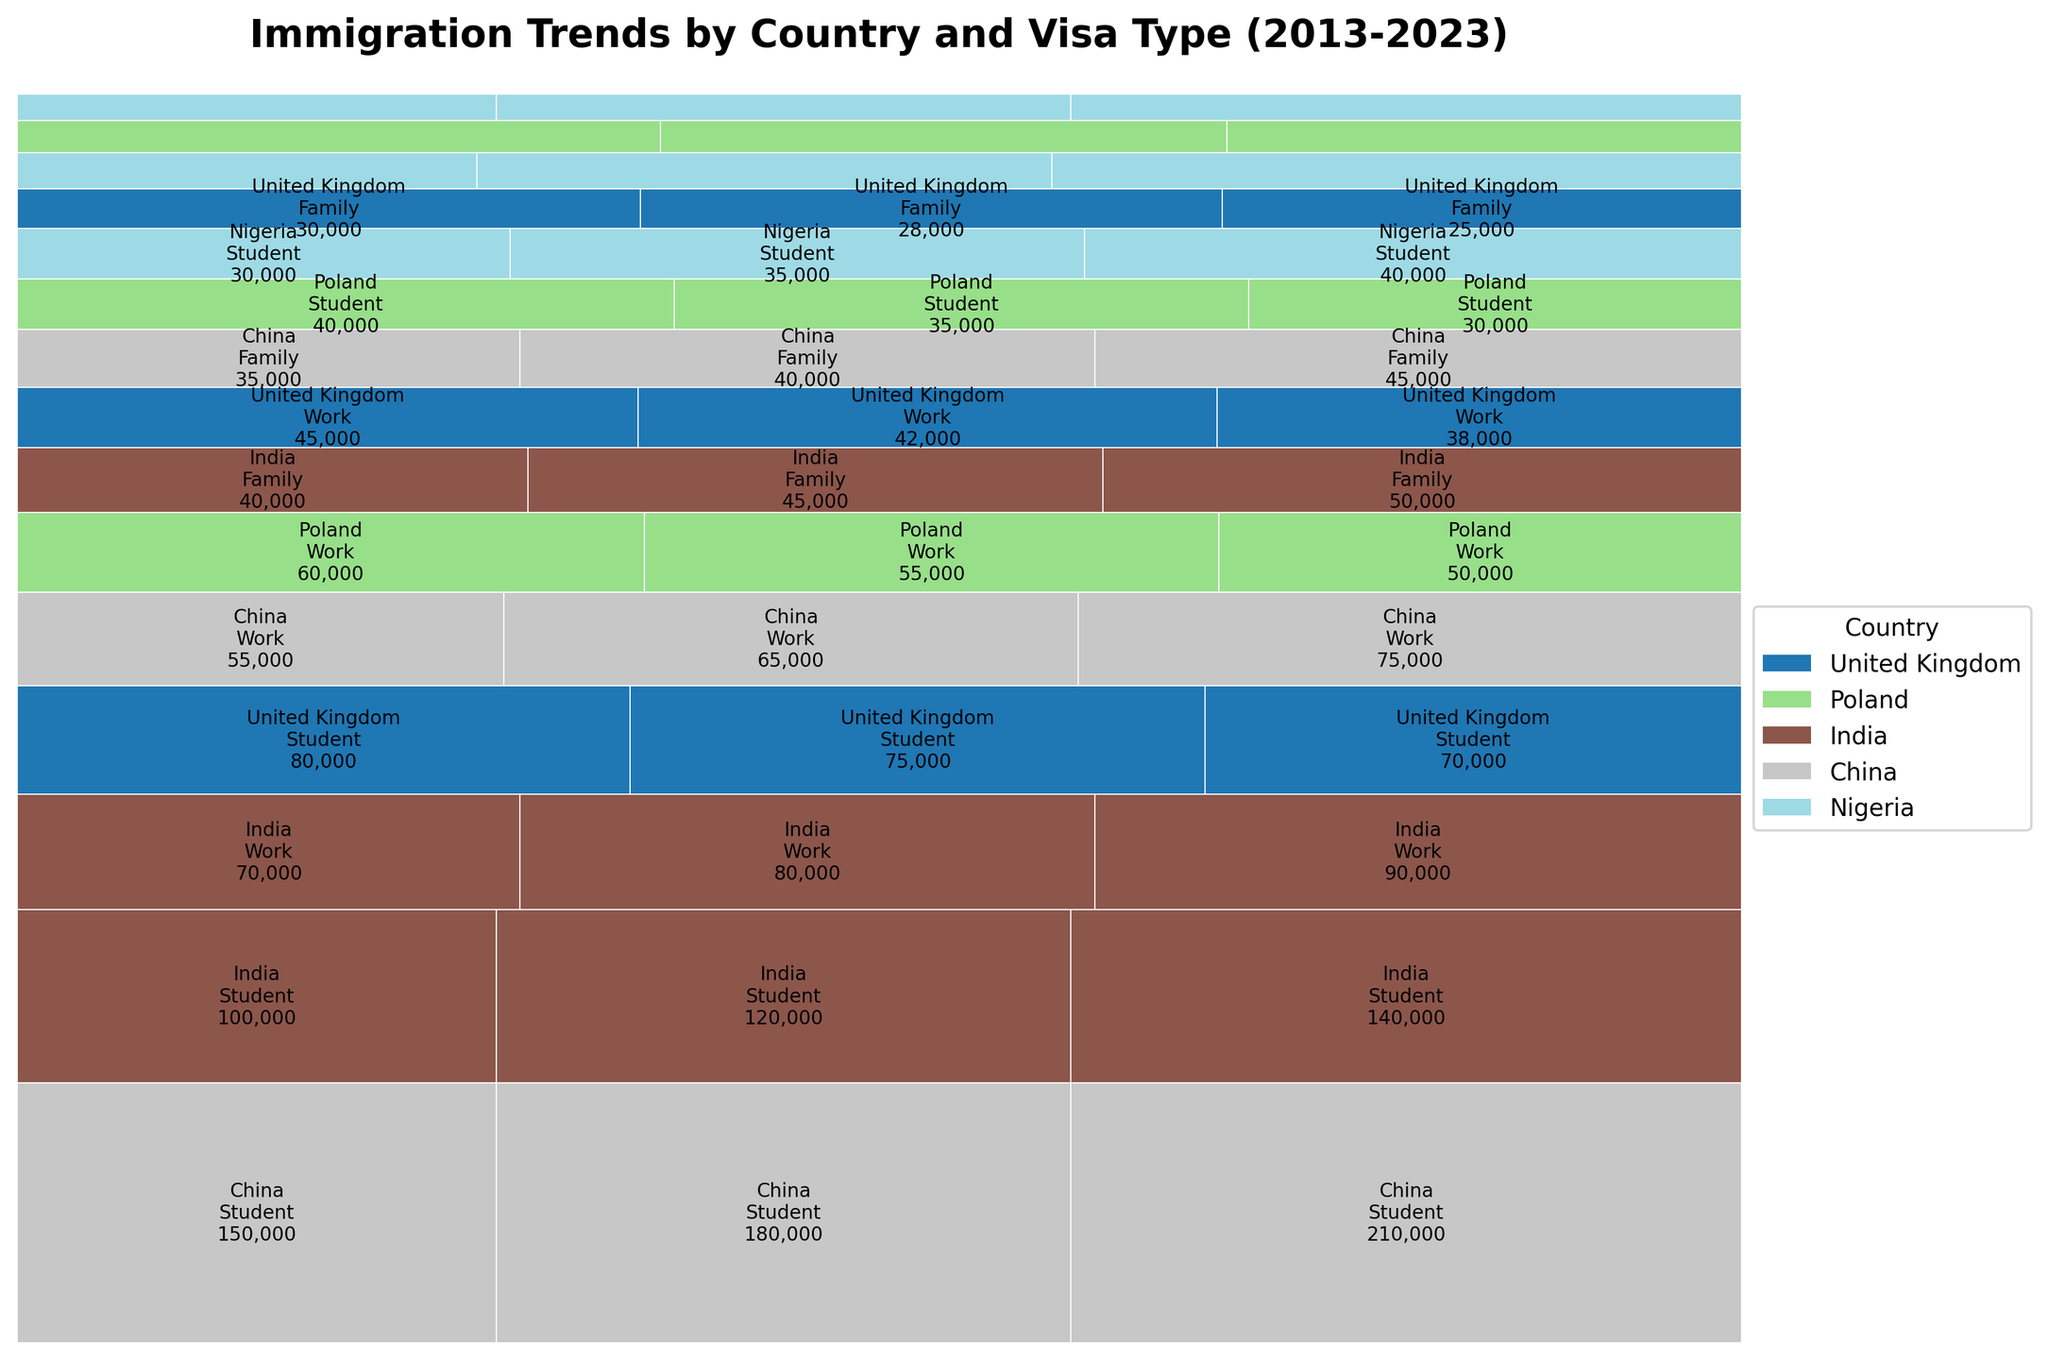What is the title of the figure? The title of the figure appears at the top in bold and larger font and summarizes the content of the graph.
Answer: Immigration Trends by Country and Visa Type (2013-2023) Which country has the largest student visa section in 2023? Observe the sections labeled with each country and corresponding to the student visa category in 2023. The largest section will be the one with the maximum area. The section labeled "China" is visibly the largest.
Answer: China How did the number of family visas issued to India change from 2013 to 2023? Look for the "Family" visa category under the "India" section for both years 2013 and 2023. Note the change in the area representing these numbers. The figures were 40,000 in 2013 and 50,000 in 2023, showing an increase of 10,000.
Answer: Increased by 10,000 Which visa type experienced the most significant decrease for the United Kingdom from 2013 to 2023? Review the sections for Work, Family, and Student visas under the United Kingdom for 2013 and 2023. Calculate the differences: Work (45,000 to 38,000 = 7,000), Family (30,000 to 25,000 = 5,000), and Student (80,000 to 70,000 = 10,000). The Student visa decreased the most.
Answer: Student Compare the trend of work visas from Poland and China between 2013 and 2023. Which country had a higher increase? Inspect the "Work" visa sections for both Poland and China in 2013 and 2023. Note the changes: Poland (60,000 to 50,000, a decrease of 10,000) and China (55,000 to 75,000, an increase of 20,000). Hence, China had a higher increase.
Answer: China Which country's data appears in the most diverse range of visa types? Examine all sections for each country, noting the range of visa types (Work, Family, Student). Most countries appear across all three visa types. Compare visual rectangles to find the country with the widest distribution across the different types and large sizes.
Answer: China How does the area size for student visas in Nigeria compare to work visas in the UK in 2023? Compare the visual size of the sections for student visas under Nigeria and work visas under the United Kingdom for 2023. The student visa section for Nigeria appears larger than the work visa section for the UK.
Answer: Larger Summarize the trend of immigration from China for all visa types from 2013 to 2023. Review the sections representing China for Work, Family, and Student visas across 2013, 2018, and 2023. Observe that all sections have increased in size from 2013 to 2023, indicating an overall increase in immigration across all visa types from China.
Answer: Increased across all visa types Identify the country that shows a decreasing trend in all visa categories from 2013 to 2023. Observe each country and their respective visa types (Work, Family, Student) from 2013 to 2023. Find the country where all sections decrease in size. The United Kingdom consistently shows a decrease in all visa categories.
Answer: United Kingdom 